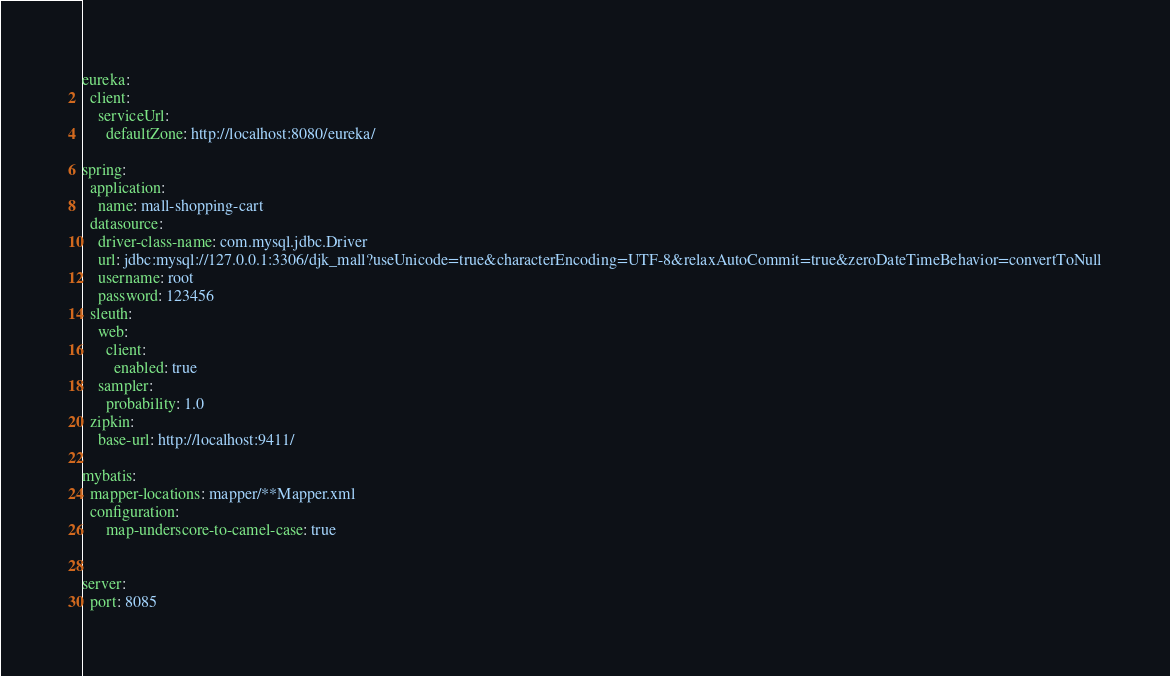<code> <loc_0><loc_0><loc_500><loc_500><_YAML_>eureka:
  client:
    serviceUrl:
      defaultZone: http://localhost:8080/eureka/

spring:
  application:
    name: mall-shopping-cart
  datasource:
    driver-class-name: com.mysql.jdbc.Driver
    url: jdbc:mysql://127.0.0.1:3306/djk_mall?useUnicode=true&characterEncoding=UTF-8&relaxAutoCommit=true&zeroDateTimeBehavior=convertToNull
    username: root
    password: 123456
  sleuth:
    web:
      client:
        enabled: true
    sampler:
      probability: 1.0
  zipkin:
    base-url: http://localhost:9411/

mybatis:
  mapper-locations: mapper/**Mapper.xml
  configuration:
      map-underscore-to-camel-case: true


server:
  port: 8085

</code> 